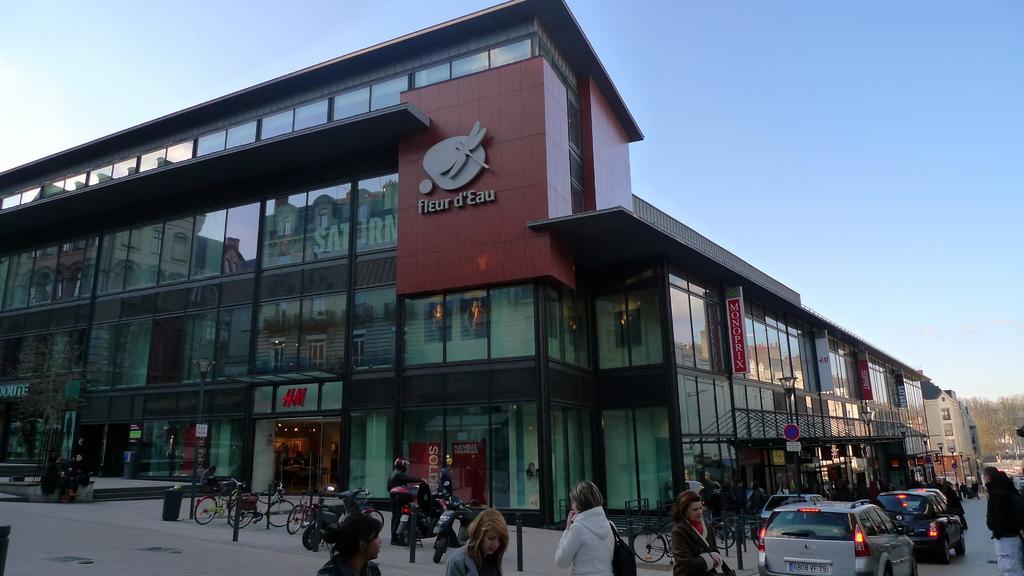Could you give a brief overview of what you see in this image? In this image there is a building and we can see people there are bicycles and cars on the road. In the background there are trees and sky. 